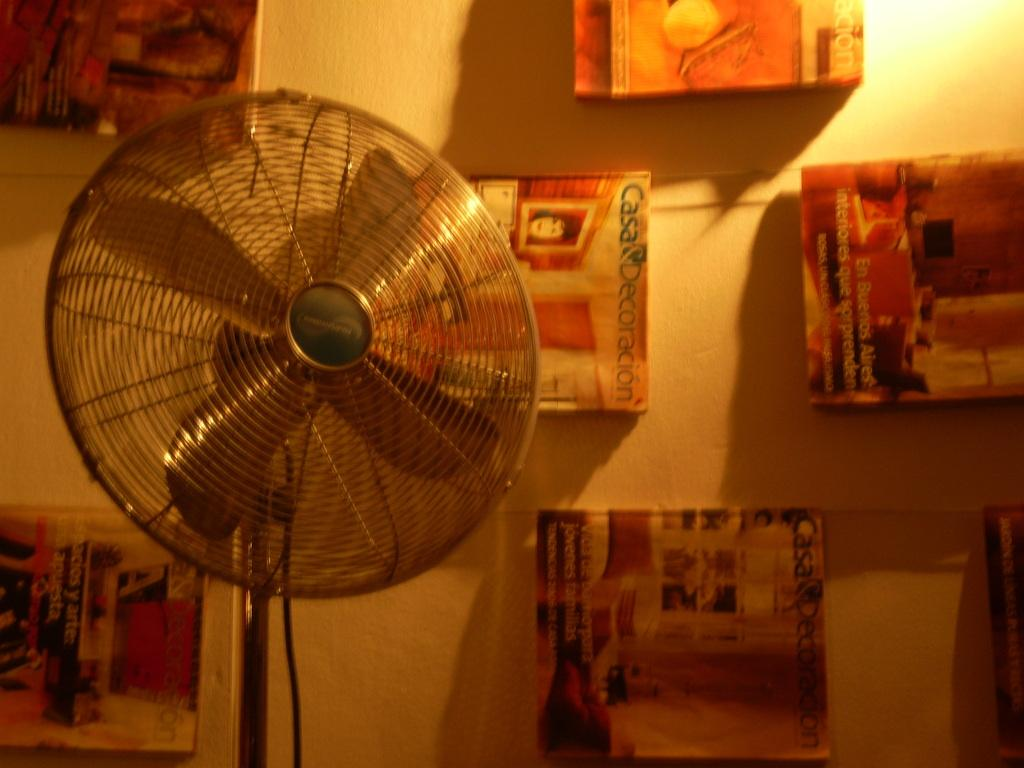<image>
Summarize the visual content of the image. Items hung on the wall include something about a "Casa". 